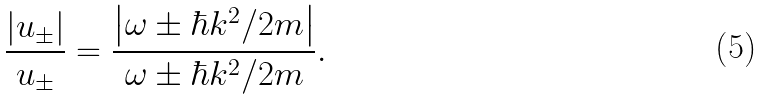Convert formula to latex. <formula><loc_0><loc_0><loc_500><loc_500>\frac { \left | u _ { \pm } \right | } { u _ { \pm } } = \frac { \left | \omega \pm \hbar { k } ^ { 2 } / 2 m \right | } { \omega \pm \hbar { k } ^ { 2 } / 2 m } .</formula> 